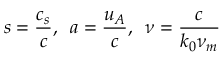<formula> <loc_0><loc_0><loc_500><loc_500>s = \frac { c _ { s } } { c } , \, a = \frac { u _ { A } } { c } , \, \nu = \frac { c } { k _ { 0 } \nu _ { m } }</formula> 